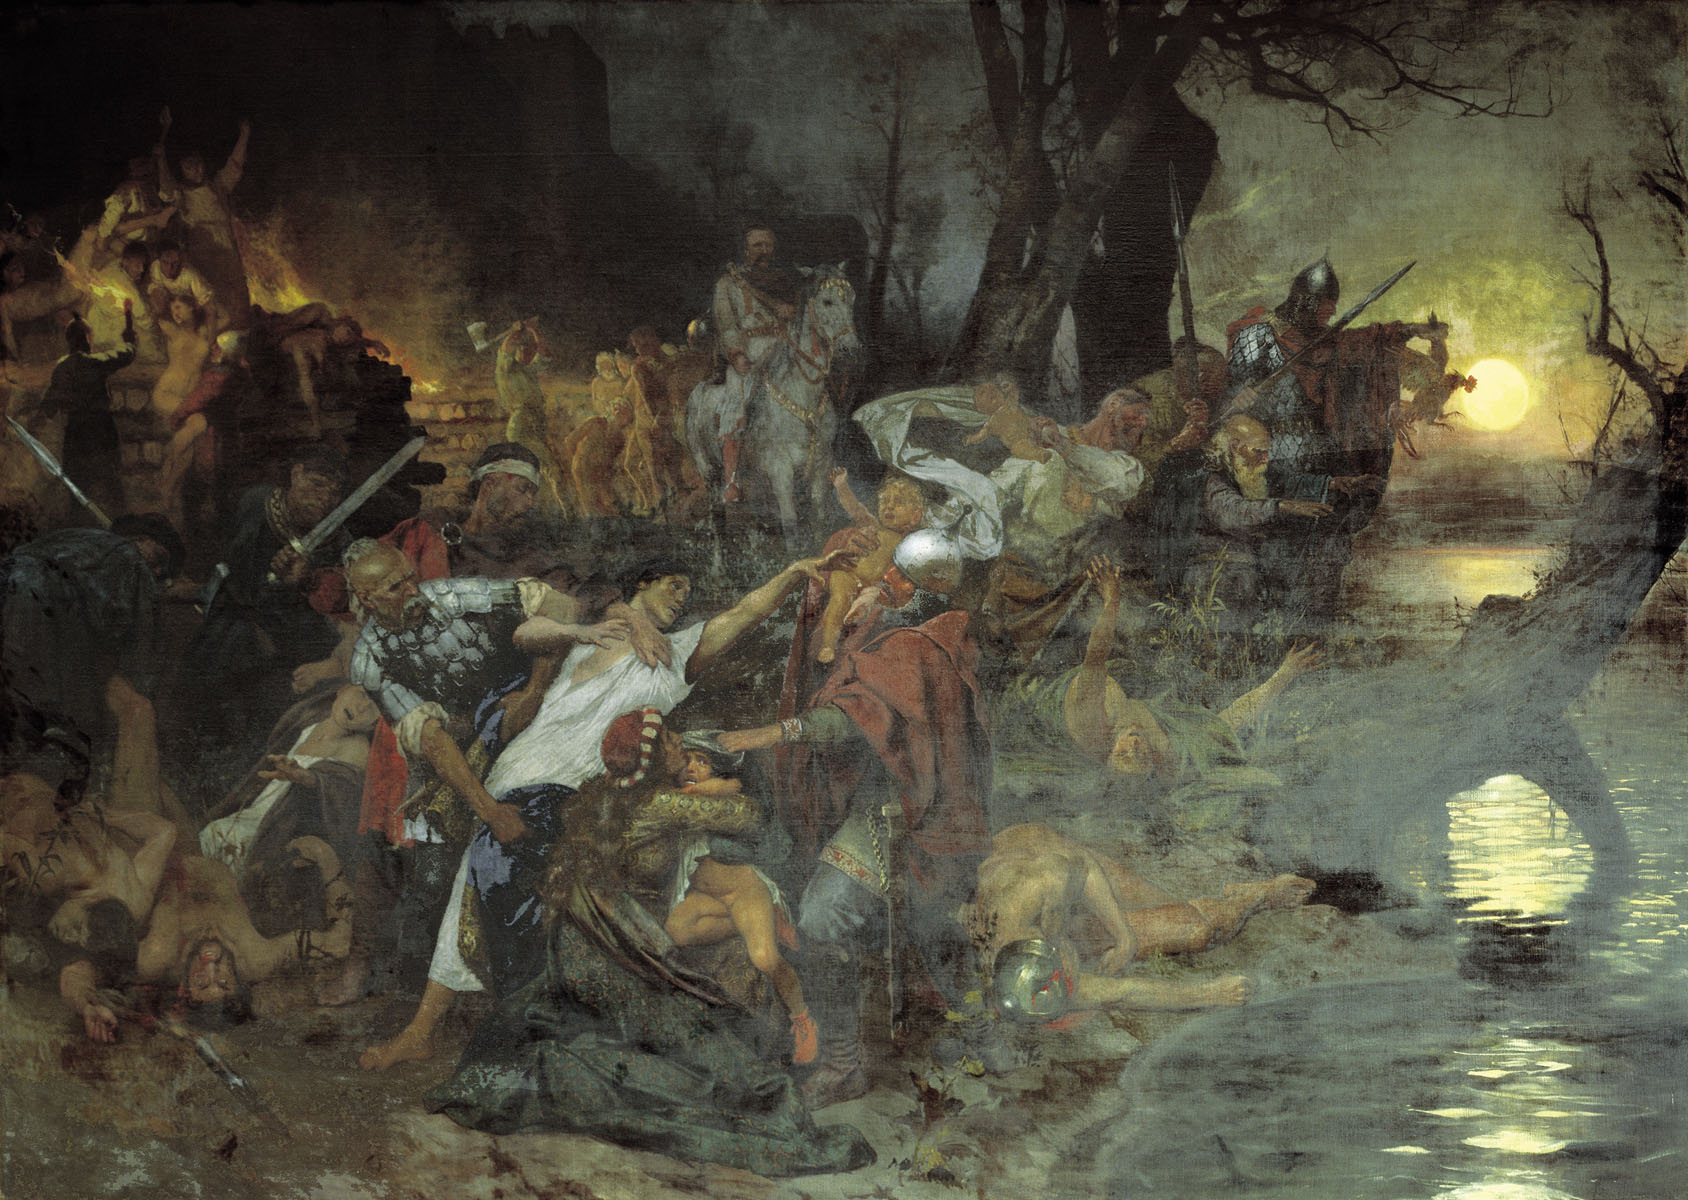What do you see happening in this image? This image captures a dramatically chaotic battle scene, likely set during a historical or medieval era. The setting is a swampy area engulfed in darkness, with an eerie glow cast by a bright yellow moon in the background. The overall gloomy atmosphere amplifies the sense of turmoil and conflict.

In the foreground, numerous figures are engaged in intense hand-to-hand combat, wielding swords and spears. The scene is chaotic with several individuals either fighting fiercely or lying defeated. The ruins of buildings and trees in the background add to the impression of a once serene place now ravaged by warfare.

The artist employs vivid colors and dynamic composition to portray the chaos and ferocity of the battle. The sharp contrast between the dark surroundings and the glowing moonlight enhances the dramatic tone of the painting. While the specific historical event being depicted is left to the viewer's interpretation, the image symbolizes the brutal and relentless nature of war, making it a powerful example of History painting. 